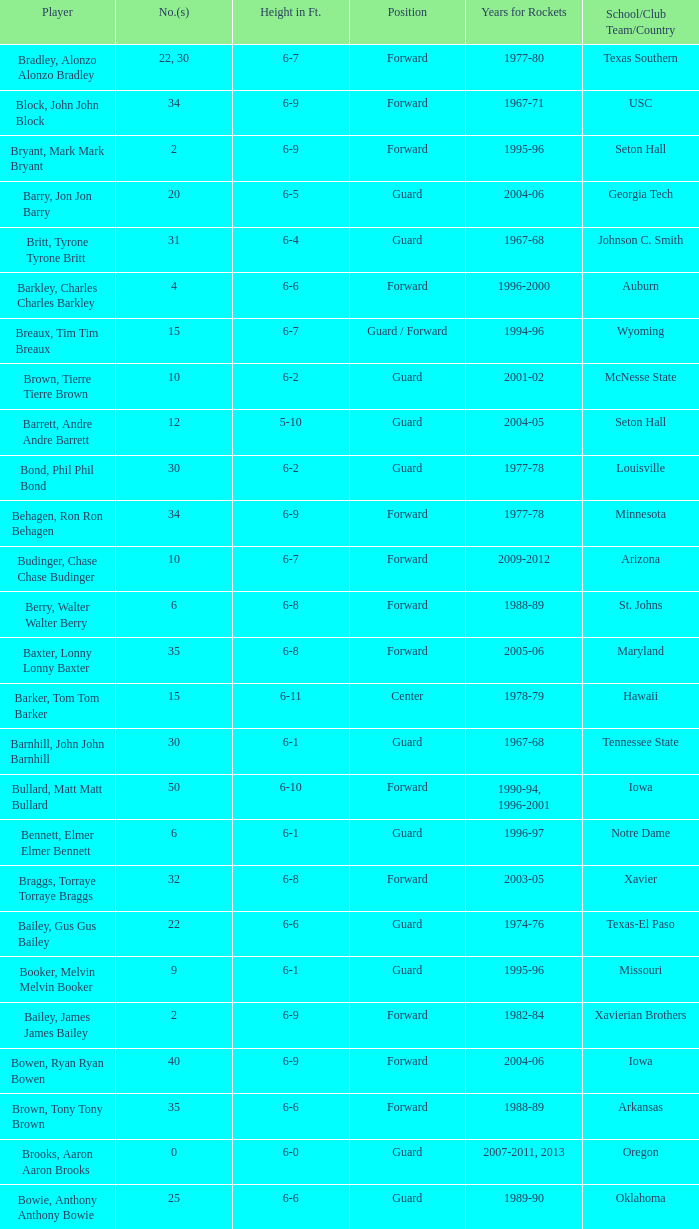What school did the forward whose number is 10 belong to? Arizona. 